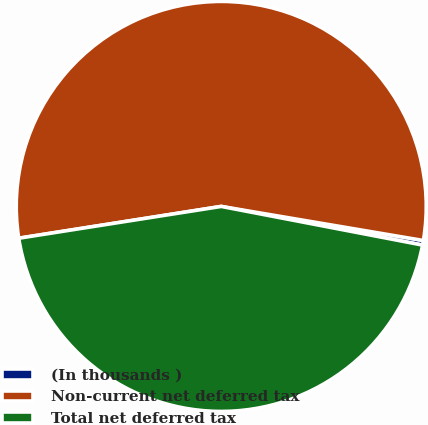Convert chart to OTSL. <chart><loc_0><loc_0><loc_500><loc_500><pie_chart><fcel>(In thousands )<fcel>Non-current net deferred tax<fcel>Total net deferred tax<nl><fcel>0.36%<fcel>55.14%<fcel>44.5%<nl></chart> 